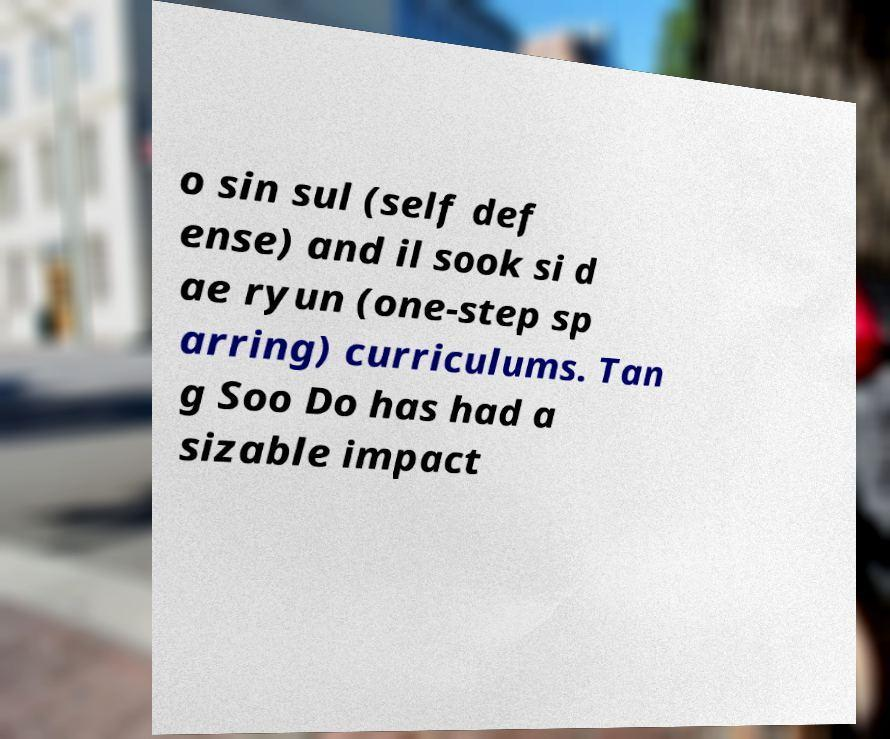Could you extract and type out the text from this image? o sin sul (self def ense) and il sook si d ae ryun (one-step sp arring) curriculums. Tan g Soo Do has had a sizable impact 